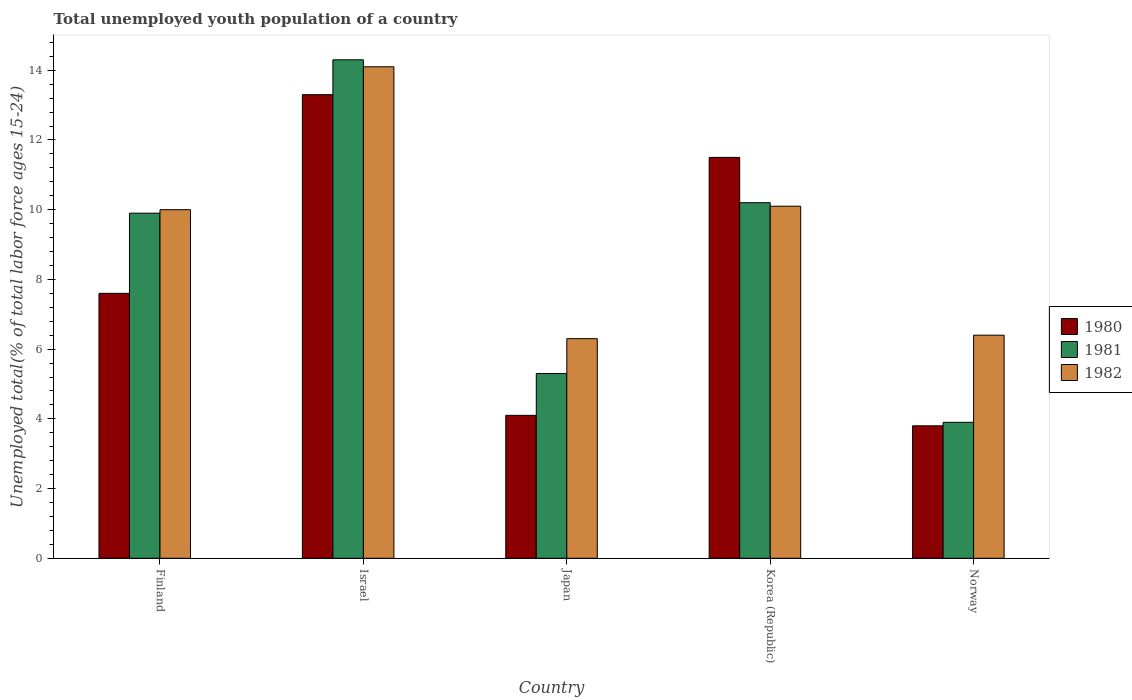How many bars are there on the 1st tick from the left?
Your response must be concise. 3. What is the label of the 5th group of bars from the left?
Make the answer very short. Norway. In how many cases, is the number of bars for a given country not equal to the number of legend labels?
Offer a very short reply. 0. What is the percentage of total unemployed youth population of a country in 1980 in Japan?
Your answer should be compact. 4.1. Across all countries, what is the maximum percentage of total unemployed youth population of a country in 1982?
Your response must be concise. 14.1. Across all countries, what is the minimum percentage of total unemployed youth population of a country in 1980?
Your response must be concise. 3.8. In which country was the percentage of total unemployed youth population of a country in 1982 maximum?
Offer a terse response. Israel. What is the total percentage of total unemployed youth population of a country in 1980 in the graph?
Your answer should be very brief. 40.3. What is the difference between the percentage of total unemployed youth population of a country in 1981 in Finland and that in Korea (Republic)?
Your answer should be very brief. -0.3. What is the difference between the percentage of total unemployed youth population of a country in 1981 in Norway and the percentage of total unemployed youth population of a country in 1980 in Korea (Republic)?
Keep it short and to the point. -7.6. What is the average percentage of total unemployed youth population of a country in 1981 per country?
Provide a succinct answer. 8.72. What is the difference between the percentage of total unemployed youth population of a country of/in 1982 and percentage of total unemployed youth population of a country of/in 1980 in Israel?
Offer a terse response. 0.8. In how many countries, is the percentage of total unemployed youth population of a country in 1980 greater than 2 %?
Your answer should be very brief. 5. What is the ratio of the percentage of total unemployed youth population of a country in 1980 in Japan to that in Korea (Republic)?
Your answer should be compact. 0.36. Is the percentage of total unemployed youth population of a country in 1980 in Japan less than that in Norway?
Make the answer very short. No. Is the difference between the percentage of total unemployed youth population of a country in 1982 in Israel and Norway greater than the difference between the percentage of total unemployed youth population of a country in 1980 in Israel and Norway?
Provide a succinct answer. No. What is the difference between the highest and the second highest percentage of total unemployed youth population of a country in 1980?
Your answer should be compact. -1.8. What is the difference between the highest and the lowest percentage of total unemployed youth population of a country in 1981?
Make the answer very short. 10.4. In how many countries, is the percentage of total unemployed youth population of a country in 1981 greater than the average percentage of total unemployed youth population of a country in 1981 taken over all countries?
Make the answer very short. 3. What does the 1st bar from the right in Korea (Republic) represents?
Your response must be concise. 1982. Is it the case that in every country, the sum of the percentage of total unemployed youth population of a country in 1982 and percentage of total unemployed youth population of a country in 1981 is greater than the percentage of total unemployed youth population of a country in 1980?
Provide a short and direct response. Yes. How many bars are there?
Your response must be concise. 15. How many countries are there in the graph?
Ensure brevity in your answer.  5. Are the values on the major ticks of Y-axis written in scientific E-notation?
Offer a terse response. No. Does the graph contain any zero values?
Your answer should be compact. No. Does the graph contain grids?
Keep it short and to the point. No. How many legend labels are there?
Your response must be concise. 3. What is the title of the graph?
Keep it short and to the point. Total unemployed youth population of a country. What is the label or title of the Y-axis?
Offer a terse response. Unemployed total(% of total labor force ages 15-24). What is the Unemployed total(% of total labor force ages 15-24) of 1980 in Finland?
Your response must be concise. 7.6. What is the Unemployed total(% of total labor force ages 15-24) in 1981 in Finland?
Keep it short and to the point. 9.9. What is the Unemployed total(% of total labor force ages 15-24) of 1982 in Finland?
Make the answer very short. 10. What is the Unemployed total(% of total labor force ages 15-24) in 1980 in Israel?
Your answer should be compact. 13.3. What is the Unemployed total(% of total labor force ages 15-24) of 1981 in Israel?
Provide a succinct answer. 14.3. What is the Unemployed total(% of total labor force ages 15-24) of 1982 in Israel?
Your response must be concise. 14.1. What is the Unemployed total(% of total labor force ages 15-24) of 1980 in Japan?
Keep it short and to the point. 4.1. What is the Unemployed total(% of total labor force ages 15-24) in 1981 in Japan?
Provide a short and direct response. 5.3. What is the Unemployed total(% of total labor force ages 15-24) of 1982 in Japan?
Ensure brevity in your answer.  6.3. What is the Unemployed total(% of total labor force ages 15-24) in 1980 in Korea (Republic)?
Give a very brief answer. 11.5. What is the Unemployed total(% of total labor force ages 15-24) in 1981 in Korea (Republic)?
Your answer should be compact. 10.2. What is the Unemployed total(% of total labor force ages 15-24) in 1982 in Korea (Republic)?
Your answer should be very brief. 10.1. What is the Unemployed total(% of total labor force ages 15-24) in 1980 in Norway?
Offer a terse response. 3.8. What is the Unemployed total(% of total labor force ages 15-24) of 1981 in Norway?
Provide a short and direct response. 3.9. What is the Unemployed total(% of total labor force ages 15-24) in 1982 in Norway?
Provide a succinct answer. 6.4. Across all countries, what is the maximum Unemployed total(% of total labor force ages 15-24) in 1980?
Your answer should be compact. 13.3. Across all countries, what is the maximum Unemployed total(% of total labor force ages 15-24) in 1981?
Make the answer very short. 14.3. Across all countries, what is the maximum Unemployed total(% of total labor force ages 15-24) of 1982?
Provide a short and direct response. 14.1. Across all countries, what is the minimum Unemployed total(% of total labor force ages 15-24) in 1980?
Offer a terse response. 3.8. Across all countries, what is the minimum Unemployed total(% of total labor force ages 15-24) of 1981?
Offer a very short reply. 3.9. Across all countries, what is the minimum Unemployed total(% of total labor force ages 15-24) of 1982?
Ensure brevity in your answer.  6.3. What is the total Unemployed total(% of total labor force ages 15-24) of 1980 in the graph?
Keep it short and to the point. 40.3. What is the total Unemployed total(% of total labor force ages 15-24) in 1981 in the graph?
Provide a short and direct response. 43.6. What is the total Unemployed total(% of total labor force ages 15-24) in 1982 in the graph?
Offer a terse response. 46.9. What is the difference between the Unemployed total(% of total labor force ages 15-24) of 1980 in Finland and that in Israel?
Give a very brief answer. -5.7. What is the difference between the Unemployed total(% of total labor force ages 15-24) of 1981 in Finland and that in Israel?
Your answer should be compact. -4.4. What is the difference between the Unemployed total(% of total labor force ages 15-24) in 1982 in Finland and that in Israel?
Provide a succinct answer. -4.1. What is the difference between the Unemployed total(% of total labor force ages 15-24) of 1981 in Finland and that in Japan?
Your answer should be compact. 4.6. What is the difference between the Unemployed total(% of total labor force ages 15-24) of 1980 in Finland and that in Korea (Republic)?
Your answer should be compact. -3.9. What is the difference between the Unemployed total(% of total labor force ages 15-24) of 1981 in Finland and that in Korea (Republic)?
Offer a very short reply. -0.3. What is the difference between the Unemployed total(% of total labor force ages 15-24) of 1982 in Finland and that in Korea (Republic)?
Your answer should be very brief. -0.1. What is the difference between the Unemployed total(% of total labor force ages 15-24) in 1982 in Finland and that in Norway?
Offer a very short reply. 3.6. What is the difference between the Unemployed total(% of total labor force ages 15-24) in 1982 in Israel and that in Korea (Republic)?
Your answer should be compact. 4. What is the difference between the Unemployed total(% of total labor force ages 15-24) of 1982 in Israel and that in Norway?
Offer a terse response. 7.7. What is the difference between the Unemployed total(% of total labor force ages 15-24) of 1980 in Japan and that in Korea (Republic)?
Offer a very short reply. -7.4. What is the difference between the Unemployed total(% of total labor force ages 15-24) in 1980 in Japan and that in Norway?
Your answer should be compact. 0.3. What is the difference between the Unemployed total(% of total labor force ages 15-24) in 1980 in Korea (Republic) and that in Norway?
Give a very brief answer. 7.7. What is the difference between the Unemployed total(% of total labor force ages 15-24) in 1980 in Finland and the Unemployed total(% of total labor force ages 15-24) in 1982 in Japan?
Make the answer very short. 1.3. What is the difference between the Unemployed total(% of total labor force ages 15-24) in 1981 in Finland and the Unemployed total(% of total labor force ages 15-24) in 1982 in Japan?
Provide a short and direct response. 3.6. What is the difference between the Unemployed total(% of total labor force ages 15-24) of 1980 in Finland and the Unemployed total(% of total labor force ages 15-24) of 1982 in Korea (Republic)?
Keep it short and to the point. -2.5. What is the difference between the Unemployed total(% of total labor force ages 15-24) of 1981 in Finland and the Unemployed total(% of total labor force ages 15-24) of 1982 in Korea (Republic)?
Offer a terse response. -0.2. What is the difference between the Unemployed total(% of total labor force ages 15-24) of 1980 in Finland and the Unemployed total(% of total labor force ages 15-24) of 1982 in Norway?
Offer a terse response. 1.2. What is the difference between the Unemployed total(% of total labor force ages 15-24) in 1981 in Finland and the Unemployed total(% of total labor force ages 15-24) in 1982 in Norway?
Give a very brief answer. 3.5. What is the difference between the Unemployed total(% of total labor force ages 15-24) in 1980 in Israel and the Unemployed total(% of total labor force ages 15-24) in 1982 in Japan?
Keep it short and to the point. 7. What is the difference between the Unemployed total(% of total labor force ages 15-24) of 1980 in Israel and the Unemployed total(% of total labor force ages 15-24) of 1981 in Korea (Republic)?
Your answer should be compact. 3.1. What is the difference between the Unemployed total(% of total labor force ages 15-24) in 1980 in Israel and the Unemployed total(% of total labor force ages 15-24) in 1982 in Korea (Republic)?
Make the answer very short. 3.2. What is the difference between the Unemployed total(% of total labor force ages 15-24) in 1981 in Israel and the Unemployed total(% of total labor force ages 15-24) in 1982 in Korea (Republic)?
Keep it short and to the point. 4.2. What is the difference between the Unemployed total(% of total labor force ages 15-24) of 1980 in Israel and the Unemployed total(% of total labor force ages 15-24) of 1981 in Norway?
Your answer should be very brief. 9.4. What is the difference between the Unemployed total(% of total labor force ages 15-24) of 1981 in Israel and the Unemployed total(% of total labor force ages 15-24) of 1982 in Norway?
Your response must be concise. 7.9. What is the difference between the Unemployed total(% of total labor force ages 15-24) in 1980 in Japan and the Unemployed total(% of total labor force ages 15-24) in 1981 in Korea (Republic)?
Keep it short and to the point. -6.1. What is the difference between the Unemployed total(% of total labor force ages 15-24) in 1980 in Korea (Republic) and the Unemployed total(% of total labor force ages 15-24) in 1981 in Norway?
Provide a succinct answer. 7.6. What is the average Unemployed total(% of total labor force ages 15-24) of 1980 per country?
Your answer should be compact. 8.06. What is the average Unemployed total(% of total labor force ages 15-24) of 1981 per country?
Make the answer very short. 8.72. What is the average Unemployed total(% of total labor force ages 15-24) of 1982 per country?
Make the answer very short. 9.38. What is the difference between the Unemployed total(% of total labor force ages 15-24) in 1980 and Unemployed total(% of total labor force ages 15-24) in 1981 in Israel?
Offer a terse response. -1. What is the difference between the Unemployed total(% of total labor force ages 15-24) of 1980 and Unemployed total(% of total labor force ages 15-24) of 1982 in Israel?
Keep it short and to the point. -0.8. What is the difference between the Unemployed total(% of total labor force ages 15-24) of 1981 and Unemployed total(% of total labor force ages 15-24) of 1982 in Japan?
Give a very brief answer. -1. What is the difference between the Unemployed total(% of total labor force ages 15-24) in 1980 and Unemployed total(% of total labor force ages 15-24) in 1982 in Korea (Republic)?
Provide a short and direct response. 1.4. What is the difference between the Unemployed total(% of total labor force ages 15-24) of 1981 and Unemployed total(% of total labor force ages 15-24) of 1982 in Korea (Republic)?
Offer a very short reply. 0.1. What is the difference between the Unemployed total(% of total labor force ages 15-24) of 1980 and Unemployed total(% of total labor force ages 15-24) of 1981 in Norway?
Provide a succinct answer. -0.1. What is the difference between the Unemployed total(% of total labor force ages 15-24) of 1980 and Unemployed total(% of total labor force ages 15-24) of 1982 in Norway?
Your answer should be very brief. -2.6. What is the difference between the Unemployed total(% of total labor force ages 15-24) in 1981 and Unemployed total(% of total labor force ages 15-24) in 1982 in Norway?
Ensure brevity in your answer.  -2.5. What is the ratio of the Unemployed total(% of total labor force ages 15-24) of 1980 in Finland to that in Israel?
Ensure brevity in your answer.  0.57. What is the ratio of the Unemployed total(% of total labor force ages 15-24) of 1981 in Finland to that in Israel?
Offer a very short reply. 0.69. What is the ratio of the Unemployed total(% of total labor force ages 15-24) of 1982 in Finland to that in Israel?
Give a very brief answer. 0.71. What is the ratio of the Unemployed total(% of total labor force ages 15-24) in 1980 in Finland to that in Japan?
Ensure brevity in your answer.  1.85. What is the ratio of the Unemployed total(% of total labor force ages 15-24) of 1981 in Finland to that in Japan?
Keep it short and to the point. 1.87. What is the ratio of the Unemployed total(% of total labor force ages 15-24) in 1982 in Finland to that in Japan?
Provide a short and direct response. 1.59. What is the ratio of the Unemployed total(% of total labor force ages 15-24) of 1980 in Finland to that in Korea (Republic)?
Offer a very short reply. 0.66. What is the ratio of the Unemployed total(% of total labor force ages 15-24) in 1981 in Finland to that in Korea (Republic)?
Ensure brevity in your answer.  0.97. What is the ratio of the Unemployed total(% of total labor force ages 15-24) in 1982 in Finland to that in Korea (Republic)?
Your answer should be compact. 0.99. What is the ratio of the Unemployed total(% of total labor force ages 15-24) in 1980 in Finland to that in Norway?
Your response must be concise. 2. What is the ratio of the Unemployed total(% of total labor force ages 15-24) in 1981 in Finland to that in Norway?
Offer a very short reply. 2.54. What is the ratio of the Unemployed total(% of total labor force ages 15-24) in 1982 in Finland to that in Norway?
Your response must be concise. 1.56. What is the ratio of the Unemployed total(% of total labor force ages 15-24) in 1980 in Israel to that in Japan?
Your answer should be compact. 3.24. What is the ratio of the Unemployed total(% of total labor force ages 15-24) of 1981 in Israel to that in Japan?
Keep it short and to the point. 2.7. What is the ratio of the Unemployed total(% of total labor force ages 15-24) of 1982 in Israel to that in Japan?
Your response must be concise. 2.24. What is the ratio of the Unemployed total(% of total labor force ages 15-24) of 1980 in Israel to that in Korea (Republic)?
Provide a succinct answer. 1.16. What is the ratio of the Unemployed total(% of total labor force ages 15-24) of 1981 in Israel to that in Korea (Republic)?
Provide a short and direct response. 1.4. What is the ratio of the Unemployed total(% of total labor force ages 15-24) of 1982 in Israel to that in Korea (Republic)?
Keep it short and to the point. 1.4. What is the ratio of the Unemployed total(% of total labor force ages 15-24) of 1980 in Israel to that in Norway?
Your response must be concise. 3.5. What is the ratio of the Unemployed total(% of total labor force ages 15-24) in 1981 in Israel to that in Norway?
Your answer should be compact. 3.67. What is the ratio of the Unemployed total(% of total labor force ages 15-24) in 1982 in Israel to that in Norway?
Make the answer very short. 2.2. What is the ratio of the Unemployed total(% of total labor force ages 15-24) in 1980 in Japan to that in Korea (Republic)?
Your answer should be very brief. 0.36. What is the ratio of the Unemployed total(% of total labor force ages 15-24) of 1981 in Japan to that in Korea (Republic)?
Your response must be concise. 0.52. What is the ratio of the Unemployed total(% of total labor force ages 15-24) of 1982 in Japan to that in Korea (Republic)?
Make the answer very short. 0.62. What is the ratio of the Unemployed total(% of total labor force ages 15-24) of 1980 in Japan to that in Norway?
Make the answer very short. 1.08. What is the ratio of the Unemployed total(% of total labor force ages 15-24) of 1981 in Japan to that in Norway?
Your answer should be compact. 1.36. What is the ratio of the Unemployed total(% of total labor force ages 15-24) in 1982 in Japan to that in Norway?
Your answer should be very brief. 0.98. What is the ratio of the Unemployed total(% of total labor force ages 15-24) in 1980 in Korea (Republic) to that in Norway?
Provide a succinct answer. 3.03. What is the ratio of the Unemployed total(% of total labor force ages 15-24) in 1981 in Korea (Republic) to that in Norway?
Your answer should be very brief. 2.62. What is the ratio of the Unemployed total(% of total labor force ages 15-24) of 1982 in Korea (Republic) to that in Norway?
Your answer should be compact. 1.58. What is the difference between the highest and the second highest Unemployed total(% of total labor force ages 15-24) of 1982?
Your answer should be very brief. 4. What is the difference between the highest and the lowest Unemployed total(% of total labor force ages 15-24) of 1982?
Your answer should be very brief. 7.8. 